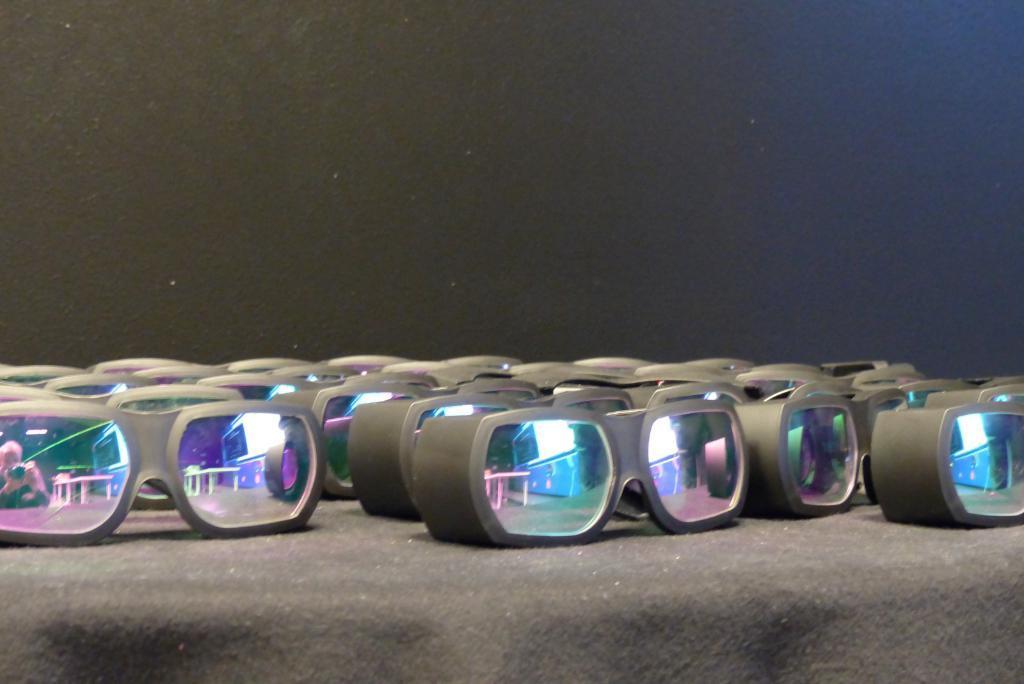Describe this image in one or two sentences. In this picture we can see goggles on the platform and in the background we can see it is dark. 